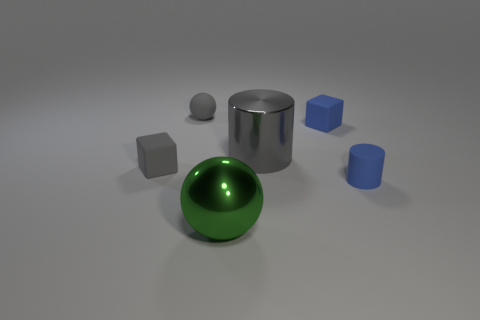How many other objects are there of the same color as the tiny rubber sphere?
Keep it short and to the point. 2. What number of objects are gray rubber blocks or tiny gray objects that are behind the tiny gray matte block?
Provide a short and direct response. 2. Are there fewer tiny gray matte objects on the left side of the small gray rubber cube than matte cubes behind the big cylinder?
Your answer should be very brief. Yes. What number of other objects are the same material as the large gray cylinder?
Ensure brevity in your answer.  1. Is the color of the big metallic thing behind the big green ball the same as the small matte sphere?
Your answer should be compact. Yes. There is a tiny blue rubber thing that is in front of the large metallic cylinder; is there a cube in front of it?
Give a very brief answer. No. There is a object that is in front of the gray cube and left of the blue cylinder; what is its material?
Offer a very short reply. Metal. What shape is the other thing that is made of the same material as the large green object?
Provide a short and direct response. Cylinder. Is the material of the cylinder on the left side of the small cylinder the same as the tiny gray cube?
Provide a short and direct response. No. There is a ball that is in front of the gray ball; what material is it?
Offer a terse response. Metal. 